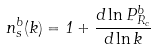Convert formula to latex. <formula><loc_0><loc_0><loc_500><loc_500>n _ { s } ^ { b } ( k ) = 1 + \frac { d \ln P ^ { b } _ { R _ { c } } } { d \ln k }</formula> 